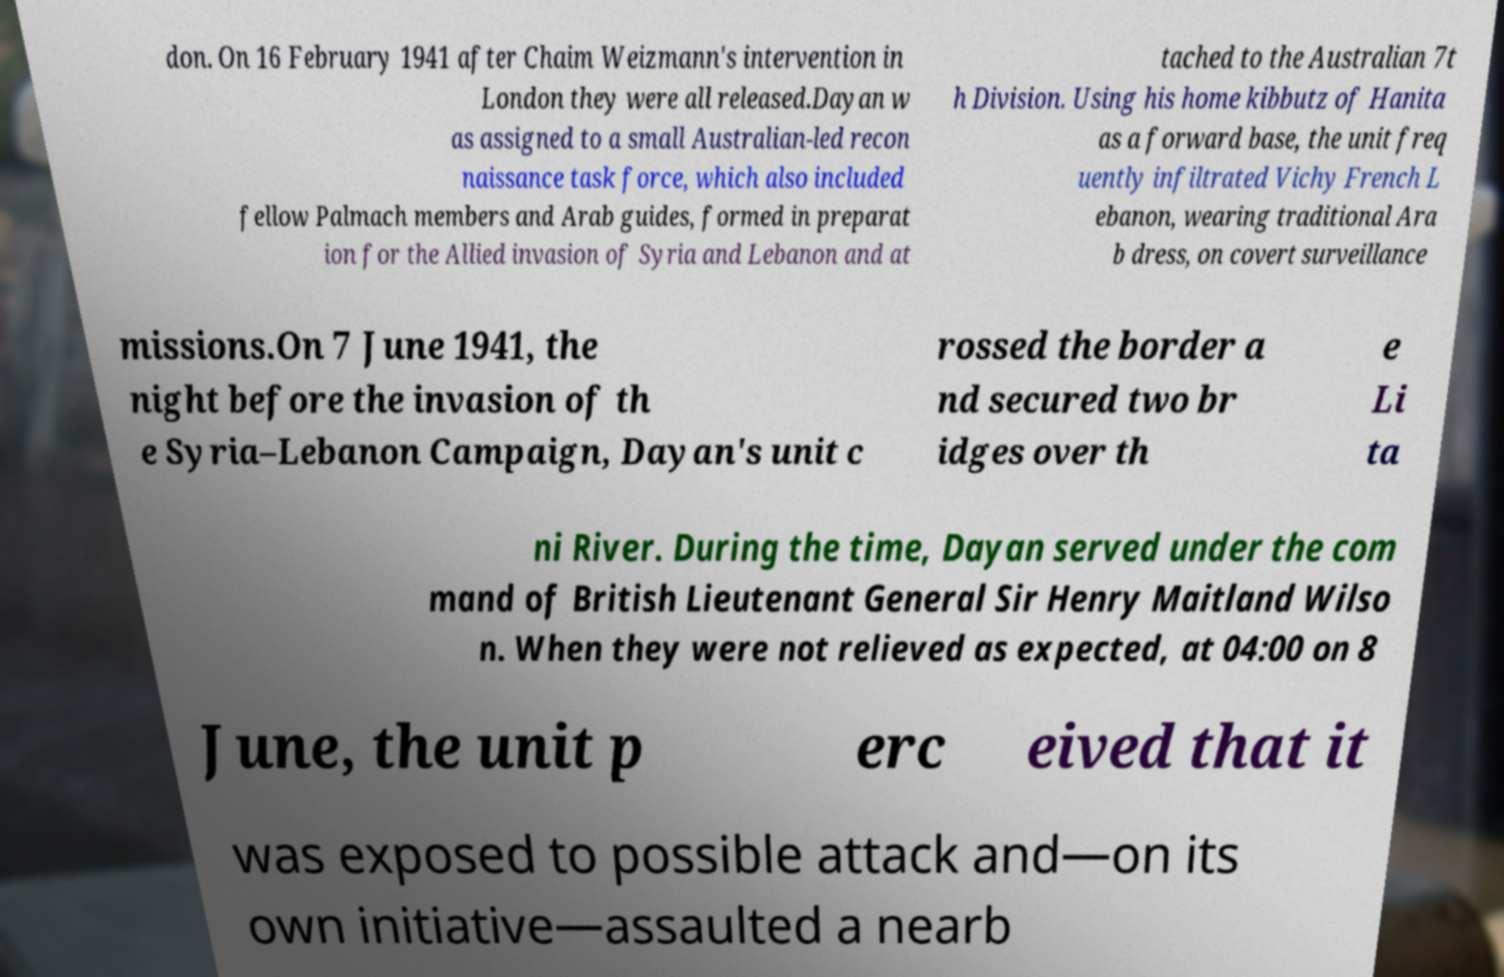Can you read and provide the text displayed in the image?This photo seems to have some interesting text. Can you extract and type it out for me? don. On 16 February 1941 after Chaim Weizmann's intervention in London they were all released.Dayan w as assigned to a small Australian-led recon naissance task force, which also included fellow Palmach members and Arab guides, formed in preparat ion for the Allied invasion of Syria and Lebanon and at tached to the Australian 7t h Division. Using his home kibbutz of Hanita as a forward base, the unit freq uently infiltrated Vichy French L ebanon, wearing traditional Ara b dress, on covert surveillance missions.On 7 June 1941, the night before the invasion of th e Syria–Lebanon Campaign, Dayan's unit c rossed the border a nd secured two br idges over th e Li ta ni River. During the time, Dayan served under the com mand of British Lieutenant General Sir Henry Maitland Wilso n. When they were not relieved as expected, at 04:00 on 8 June, the unit p erc eived that it was exposed to possible attack and—on its own initiative—assaulted a nearb 